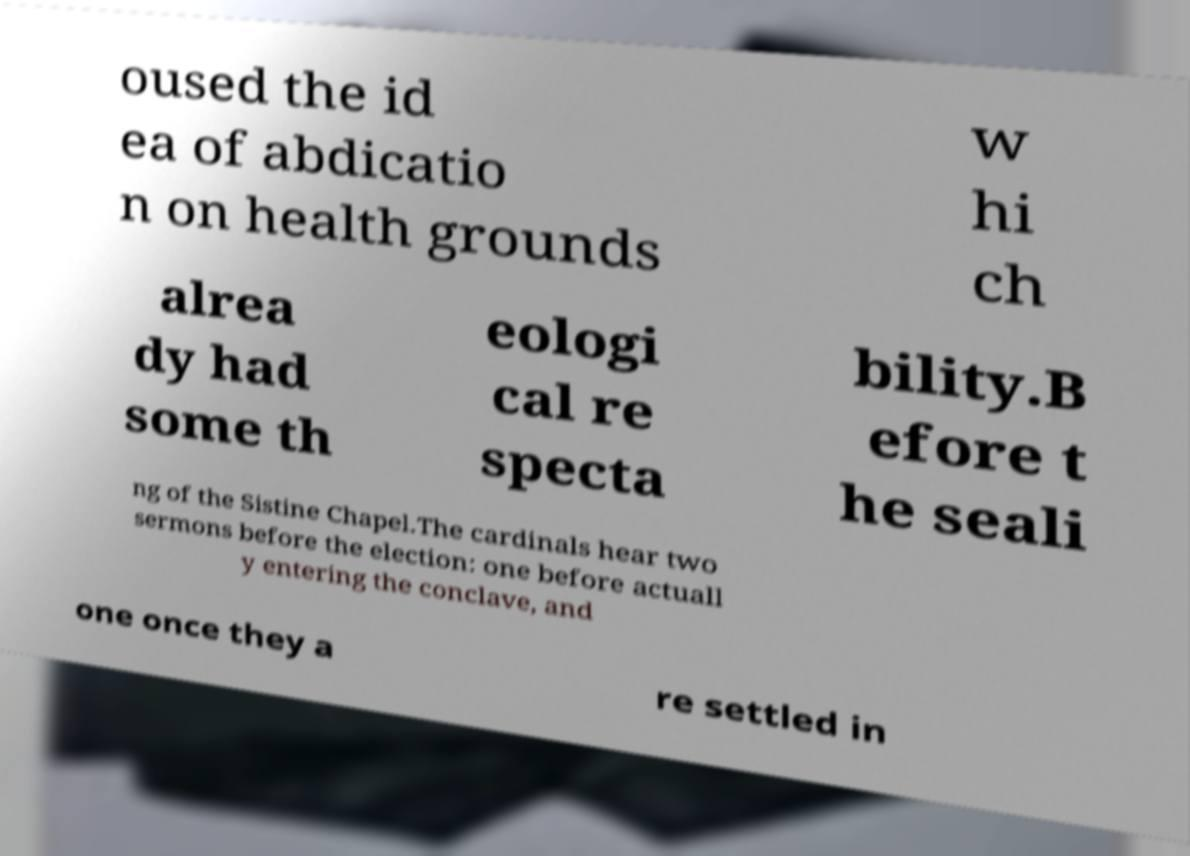What messages or text are displayed in this image? I need them in a readable, typed format. oused the id ea of abdicatio n on health grounds w hi ch alrea dy had some th eologi cal re specta bility.B efore t he seali ng of the Sistine Chapel.The cardinals hear two sermons before the election: one before actuall y entering the conclave, and one once they a re settled in 